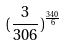Convert formula to latex. <formula><loc_0><loc_0><loc_500><loc_500>( \frac { 3 } { 3 0 6 } ) ^ { \frac { 3 4 0 } { 6 } }</formula> 